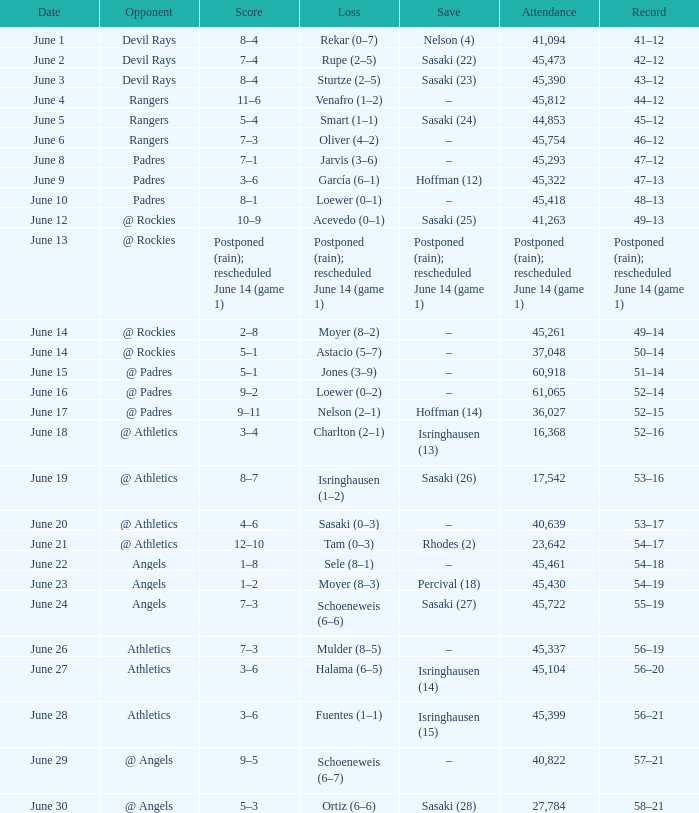What was the date of the Mariners game when they had a record of 53–17? June 20. 